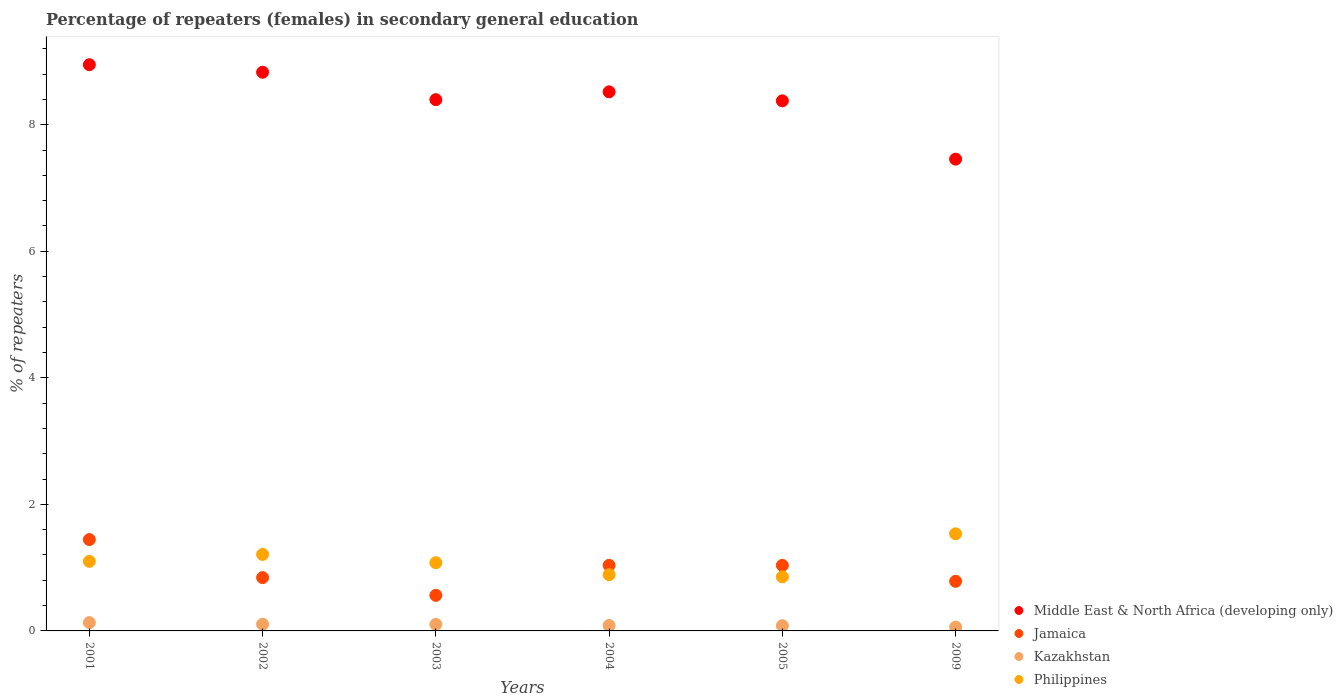Is the number of dotlines equal to the number of legend labels?
Provide a short and direct response. Yes. What is the percentage of female repeaters in Philippines in 2003?
Your response must be concise. 1.08. Across all years, what is the maximum percentage of female repeaters in Jamaica?
Your response must be concise. 1.44. Across all years, what is the minimum percentage of female repeaters in Philippines?
Keep it short and to the point. 0.85. What is the total percentage of female repeaters in Middle East & North Africa (developing only) in the graph?
Offer a very short reply. 50.53. What is the difference between the percentage of female repeaters in Philippines in 2003 and that in 2004?
Your answer should be compact. 0.19. What is the difference between the percentage of female repeaters in Middle East & North Africa (developing only) in 2004 and the percentage of female repeaters in Kazakhstan in 2002?
Provide a short and direct response. 8.41. What is the average percentage of female repeaters in Jamaica per year?
Offer a terse response. 0.95. In the year 2005, what is the difference between the percentage of female repeaters in Jamaica and percentage of female repeaters in Middle East & North Africa (developing only)?
Give a very brief answer. -7.34. In how many years, is the percentage of female repeaters in Kazakhstan greater than 0.8 %?
Your response must be concise. 0. What is the ratio of the percentage of female repeaters in Philippines in 2001 to that in 2002?
Keep it short and to the point. 0.91. Is the percentage of female repeaters in Middle East & North Africa (developing only) in 2004 less than that in 2009?
Provide a short and direct response. No. What is the difference between the highest and the second highest percentage of female repeaters in Kazakhstan?
Offer a very short reply. 0.03. What is the difference between the highest and the lowest percentage of female repeaters in Philippines?
Offer a very short reply. 0.68. In how many years, is the percentage of female repeaters in Middle East & North Africa (developing only) greater than the average percentage of female repeaters in Middle East & North Africa (developing only) taken over all years?
Provide a short and direct response. 3. Is the sum of the percentage of female repeaters in Kazakhstan in 2004 and 2009 greater than the maximum percentage of female repeaters in Philippines across all years?
Make the answer very short. No. Is it the case that in every year, the sum of the percentage of female repeaters in Middle East & North Africa (developing only) and percentage of female repeaters in Philippines  is greater than the sum of percentage of female repeaters in Kazakhstan and percentage of female repeaters in Jamaica?
Your answer should be very brief. No. Is it the case that in every year, the sum of the percentage of female repeaters in Jamaica and percentage of female repeaters in Middle East & North Africa (developing only)  is greater than the percentage of female repeaters in Philippines?
Provide a short and direct response. Yes. Are the values on the major ticks of Y-axis written in scientific E-notation?
Your response must be concise. No. Does the graph contain grids?
Give a very brief answer. No. How are the legend labels stacked?
Keep it short and to the point. Vertical. What is the title of the graph?
Give a very brief answer. Percentage of repeaters (females) in secondary general education. Does "Seychelles" appear as one of the legend labels in the graph?
Your answer should be compact. No. What is the label or title of the X-axis?
Ensure brevity in your answer.  Years. What is the label or title of the Y-axis?
Offer a terse response. % of repeaters. What is the % of repeaters in Middle East & North Africa (developing only) in 2001?
Ensure brevity in your answer.  8.95. What is the % of repeaters of Jamaica in 2001?
Make the answer very short. 1.44. What is the % of repeaters in Kazakhstan in 2001?
Offer a very short reply. 0.13. What is the % of repeaters in Philippines in 2001?
Keep it short and to the point. 1.1. What is the % of repeaters of Middle East & North Africa (developing only) in 2002?
Give a very brief answer. 8.83. What is the % of repeaters in Jamaica in 2002?
Offer a very short reply. 0.84. What is the % of repeaters in Kazakhstan in 2002?
Offer a very short reply. 0.11. What is the % of repeaters of Philippines in 2002?
Offer a terse response. 1.21. What is the % of repeaters in Middle East & North Africa (developing only) in 2003?
Offer a terse response. 8.4. What is the % of repeaters of Jamaica in 2003?
Ensure brevity in your answer.  0.56. What is the % of repeaters in Kazakhstan in 2003?
Offer a very short reply. 0.1. What is the % of repeaters of Philippines in 2003?
Your answer should be compact. 1.08. What is the % of repeaters in Middle East & North Africa (developing only) in 2004?
Provide a succinct answer. 8.52. What is the % of repeaters in Jamaica in 2004?
Provide a succinct answer. 1.04. What is the % of repeaters in Kazakhstan in 2004?
Make the answer very short. 0.09. What is the % of repeaters of Philippines in 2004?
Make the answer very short. 0.89. What is the % of repeaters in Middle East & North Africa (developing only) in 2005?
Offer a very short reply. 8.38. What is the % of repeaters of Jamaica in 2005?
Ensure brevity in your answer.  1.04. What is the % of repeaters in Kazakhstan in 2005?
Ensure brevity in your answer.  0.08. What is the % of repeaters of Philippines in 2005?
Your answer should be compact. 0.85. What is the % of repeaters of Middle East & North Africa (developing only) in 2009?
Offer a terse response. 7.46. What is the % of repeaters of Jamaica in 2009?
Offer a very short reply. 0.78. What is the % of repeaters in Kazakhstan in 2009?
Your answer should be compact. 0.06. What is the % of repeaters in Philippines in 2009?
Your answer should be very brief. 1.53. Across all years, what is the maximum % of repeaters in Middle East & North Africa (developing only)?
Ensure brevity in your answer.  8.95. Across all years, what is the maximum % of repeaters in Jamaica?
Your response must be concise. 1.44. Across all years, what is the maximum % of repeaters in Kazakhstan?
Your answer should be very brief. 0.13. Across all years, what is the maximum % of repeaters of Philippines?
Provide a succinct answer. 1.53. Across all years, what is the minimum % of repeaters of Middle East & North Africa (developing only)?
Your response must be concise. 7.46. Across all years, what is the minimum % of repeaters of Jamaica?
Your response must be concise. 0.56. Across all years, what is the minimum % of repeaters of Kazakhstan?
Your answer should be very brief. 0.06. Across all years, what is the minimum % of repeaters of Philippines?
Offer a terse response. 0.85. What is the total % of repeaters of Middle East & North Africa (developing only) in the graph?
Give a very brief answer. 50.53. What is the total % of repeaters in Jamaica in the graph?
Your answer should be very brief. 5.71. What is the total % of repeaters in Kazakhstan in the graph?
Provide a short and direct response. 0.57. What is the total % of repeaters in Philippines in the graph?
Provide a succinct answer. 6.66. What is the difference between the % of repeaters of Middle East & North Africa (developing only) in 2001 and that in 2002?
Your answer should be very brief. 0.12. What is the difference between the % of repeaters of Jamaica in 2001 and that in 2002?
Your answer should be very brief. 0.6. What is the difference between the % of repeaters of Kazakhstan in 2001 and that in 2002?
Make the answer very short. 0.03. What is the difference between the % of repeaters of Philippines in 2001 and that in 2002?
Give a very brief answer. -0.11. What is the difference between the % of repeaters in Middle East & North Africa (developing only) in 2001 and that in 2003?
Your answer should be very brief. 0.55. What is the difference between the % of repeaters in Jamaica in 2001 and that in 2003?
Offer a very short reply. 0.88. What is the difference between the % of repeaters in Kazakhstan in 2001 and that in 2003?
Give a very brief answer. 0.03. What is the difference between the % of repeaters in Philippines in 2001 and that in 2003?
Your response must be concise. 0.02. What is the difference between the % of repeaters of Middle East & North Africa (developing only) in 2001 and that in 2004?
Ensure brevity in your answer.  0.43. What is the difference between the % of repeaters of Jamaica in 2001 and that in 2004?
Keep it short and to the point. 0.41. What is the difference between the % of repeaters in Kazakhstan in 2001 and that in 2004?
Give a very brief answer. 0.05. What is the difference between the % of repeaters in Philippines in 2001 and that in 2004?
Your response must be concise. 0.21. What is the difference between the % of repeaters in Middle East & North Africa (developing only) in 2001 and that in 2005?
Make the answer very short. 0.57. What is the difference between the % of repeaters in Jamaica in 2001 and that in 2005?
Make the answer very short. 0.41. What is the difference between the % of repeaters in Kazakhstan in 2001 and that in 2005?
Give a very brief answer. 0.05. What is the difference between the % of repeaters of Philippines in 2001 and that in 2005?
Your answer should be compact. 0.24. What is the difference between the % of repeaters of Middle East & North Africa (developing only) in 2001 and that in 2009?
Make the answer very short. 1.49. What is the difference between the % of repeaters in Jamaica in 2001 and that in 2009?
Your answer should be very brief. 0.66. What is the difference between the % of repeaters in Kazakhstan in 2001 and that in 2009?
Keep it short and to the point. 0.07. What is the difference between the % of repeaters of Philippines in 2001 and that in 2009?
Your answer should be very brief. -0.44. What is the difference between the % of repeaters in Middle East & North Africa (developing only) in 2002 and that in 2003?
Your answer should be compact. 0.43. What is the difference between the % of repeaters of Jamaica in 2002 and that in 2003?
Keep it short and to the point. 0.28. What is the difference between the % of repeaters in Kazakhstan in 2002 and that in 2003?
Ensure brevity in your answer.  0. What is the difference between the % of repeaters in Philippines in 2002 and that in 2003?
Offer a terse response. 0.13. What is the difference between the % of repeaters of Middle East & North Africa (developing only) in 2002 and that in 2004?
Give a very brief answer. 0.31. What is the difference between the % of repeaters in Jamaica in 2002 and that in 2004?
Provide a short and direct response. -0.19. What is the difference between the % of repeaters of Kazakhstan in 2002 and that in 2004?
Your response must be concise. 0.02. What is the difference between the % of repeaters of Philippines in 2002 and that in 2004?
Your response must be concise. 0.32. What is the difference between the % of repeaters of Middle East & North Africa (developing only) in 2002 and that in 2005?
Your answer should be very brief. 0.45. What is the difference between the % of repeaters of Jamaica in 2002 and that in 2005?
Keep it short and to the point. -0.19. What is the difference between the % of repeaters of Kazakhstan in 2002 and that in 2005?
Keep it short and to the point. 0.02. What is the difference between the % of repeaters of Philippines in 2002 and that in 2005?
Provide a succinct answer. 0.35. What is the difference between the % of repeaters of Middle East & North Africa (developing only) in 2002 and that in 2009?
Offer a terse response. 1.37. What is the difference between the % of repeaters of Jamaica in 2002 and that in 2009?
Provide a succinct answer. 0.06. What is the difference between the % of repeaters in Kazakhstan in 2002 and that in 2009?
Provide a succinct answer. 0.05. What is the difference between the % of repeaters in Philippines in 2002 and that in 2009?
Provide a short and direct response. -0.33. What is the difference between the % of repeaters of Middle East & North Africa (developing only) in 2003 and that in 2004?
Provide a succinct answer. -0.12. What is the difference between the % of repeaters of Jamaica in 2003 and that in 2004?
Give a very brief answer. -0.47. What is the difference between the % of repeaters of Kazakhstan in 2003 and that in 2004?
Your answer should be very brief. 0.02. What is the difference between the % of repeaters of Philippines in 2003 and that in 2004?
Your response must be concise. 0.19. What is the difference between the % of repeaters of Middle East & North Africa (developing only) in 2003 and that in 2005?
Offer a very short reply. 0.02. What is the difference between the % of repeaters of Jamaica in 2003 and that in 2005?
Provide a short and direct response. -0.47. What is the difference between the % of repeaters in Kazakhstan in 2003 and that in 2005?
Offer a terse response. 0.02. What is the difference between the % of repeaters of Philippines in 2003 and that in 2005?
Give a very brief answer. 0.22. What is the difference between the % of repeaters in Middle East & North Africa (developing only) in 2003 and that in 2009?
Keep it short and to the point. 0.94. What is the difference between the % of repeaters in Jamaica in 2003 and that in 2009?
Provide a succinct answer. -0.22. What is the difference between the % of repeaters of Kazakhstan in 2003 and that in 2009?
Keep it short and to the point. 0.04. What is the difference between the % of repeaters in Philippines in 2003 and that in 2009?
Your response must be concise. -0.46. What is the difference between the % of repeaters of Middle East & North Africa (developing only) in 2004 and that in 2005?
Give a very brief answer. 0.14. What is the difference between the % of repeaters of Jamaica in 2004 and that in 2005?
Keep it short and to the point. -0. What is the difference between the % of repeaters of Kazakhstan in 2004 and that in 2005?
Provide a succinct answer. 0. What is the difference between the % of repeaters of Philippines in 2004 and that in 2005?
Offer a very short reply. 0.03. What is the difference between the % of repeaters of Middle East & North Africa (developing only) in 2004 and that in 2009?
Provide a succinct answer. 1.06. What is the difference between the % of repeaters of Jamaica in 2004 and that in 2009?
Offer a terse response. 0.25. What is the difference between the % of repeaters of Kazakhstan in 2004 and that in 2009?
Keep it short and to the point. 0.03. What is the difference between the % of repeaters of Philippines in 2004 and that in 2009?
Keep it short and to the point. -0.65. What is the difference between the % of repeaters in Middle East & North Africa (developing only) in 2005 and that in 2009?
Your answer should be compact. 0.92. What is the difference between the % of repeaters in Jamaica in 2005 and that in 2009?
Provide a short and direct response. 0.25. What is the difference between the % of repeaters of Kazakhstan in 2005 and that in 2009?
Offer a very short reply. 0.02. What is the difference between the % of repeaters of Philippines in 2005 and that in 2009?
Provide a short and direct response. -0.68. What is the difference between the % of repeaters in Middle East & North Africa (developing only) in 2001 and the % of repeaters in Jamaica in 2002?
Your response must be concise. 8.11. What is the difference between the % of repeaters of Middle East & North Africa (developing only) in 2001 and the % of repeaters of Kazakhstan in 2002?
Offer a terse response. 8.84. What is the difference between the % of repeaters in Middle East & North Africa (developing only) in 2001 and the % of repeaters in Philippines in 2002?
Your answer should be very brief. 7.74. What is the difference between the % of repeaters in Jamaica in 2001 and the % of repeaters in Kazakhstan in 2002?
Keep it short and to the point. 1.34. What is the difference between the % of repeaters in Jamaica in 2001 and the % of repeaters in Philippines in 2002?
Offer a terse response. 0.23. What is the difference between the % of repeaters of Kazakhstan in 2001 and the % of repeaters of Philippines in 2002?
Provide a succinct answer. -1.08. What is the difference between the % of repeaters in Middle East & North Africa (developing only) in 2001 and the % of repeaters in Jamaica in 2003?
Your answer should be very brief. 8.39. What is the difference between the % of repeaters in Middle East & North Africa (developing only) in 2001 and the % of repeaters in Kazakhstan in 2003?
Your answer should be very brief. 8.85. What is the difference between the % of repeaters of Middle East & North Africa (developing only) in 2001 and the % of repeaters of Philippines in 2003?
Your answer should be very brief. 7.87. What is the difference between the % of repeaters of Jamaica in 2001 and the % of repeaters of Kazakhstan in 2003?
Your answer should be compact. 1.34. What is the difference between the % of repeaters of Jamaica in 2001 and the % of repeaters of Philippines in 2003?
Provide a succinct answer. 0.37. What is the difference between the % of repeaters in Kazakhstan in 2001 and the % of repeaters in Philippines in 2003?
Give a very brief answer. -0.95. What is the difference between the % of repeaters in Middle East & North Africa (developing only) in 2001 and the % of repeaters in Jamaica in 2004?
Make the answer very short. 7.91. What is the difference between the % of repeaters of Middle East & North Africa (developing only) in 2001 and the % of repeaters of Kazakhstan in 2004?
Provide a short and direct response. 8.86. What is the difference between the % of repeaters of Middle East & North Africa (developing only) in 2001 and the % of repeaters of Philippines in 2004?
Keep it short and to the point. 8.06. What is the difference between the % of repeaters of Jamaica in 2001 and the % of repeaters of Kazakhstan in 2004?
Ensure brevity in your answer.  1.36. What is the difference between the % of repeaters of Jamaica in 2001 and the % of repeaters of Philippines in 2004?
Make the answer very short. 0.56. What is the difference between the % of repeaters of Kazakhstan in 2001 and the % of repeaters of Philippines in 2004?
Give a very brief answer. -0.76. What is the difference between the % of repeaters of Middle East & North Africa (developing only) in 2001 and the % of repeaters of Jamaica in 2005?
Your answer should be very brief. 7.91. What is the difference between the % of repeaters of Middle East & North Africa (developing only) in 2001 and the % of repeaters of Kazakhstan in 2005?
Make the answer very short. 8.87. What is the difference between the % of repeaters of Middle East & North Africa (developing only) in 2001 and the % of repeaters of Philippines in 2005?
Your response must be concise. 8.09. What is the difference between the % of repeaters in Jamaica in 2001 and the % of repeaters in Kazakhstan in 2005?
Offer a very short reply. 1.36. What is the difference between the % of repeaters in Jamaica in 2001 and the % of repeaters in Philippines in 2005?
Ensure brevity in your answer.  0.59. What is the difference between the % of repeaters of Kazakhstan in 2001 and the % of repeaters of Philippines in 2005?
Give a very brief answer. -0.72. What is the difference between the % of repeaters in Middle East & North Africa (developing only) in 2001 and the % of repeaters in Jamaica in 2009?
Make the answer very short. 8.16. What is the difference between the % of repeaters in Middle East & North Africa (developing only) in 2001 and the % of repeaters in Kazakhstan in 2009?
Provide a succinct answer. 8.89. What is the difference between the % of repeaters in Middle East & North Africa (developing only) in 2001 and the % of repeaters in Philippines in 2009?
Keep it short and to the point. 7.41. What is the difference between the % of repeaters in Jamaica in 2001 and the % of repeaters in Kazakhstan in 2009?
Provide a succinct answer. 1.38. What is the difference between the % of repeaters of Jamaica in 2001 and the % of repeaters of Philippines in 2009?
Your response must be concise. -0.09. What is the difference between the % of repeaters of Kazakhstan in 2001 and the % of repeaters of Philippines in 2009?
Make the answer very short. -1.4. What is the difference between the % of repeaters of Middle East & North Africa (developing only) in 2002 and the % of repeaters of Jamaica in 2003?
Provide a short and direct response. 8.27. What is the difference between the % of repeaters of Middle East & North Africa (developing only) in 2002 and the % of repeaters of Kazakhstan in 2003?
Offer a very short reply. 8.73. What is the difference between the % of repeaters of Middle East & North Africa (developing only) in 2002 and the % of repeaters of Philippines in 2003?
Offer a terse response. 7.75. What is the difference between the % of repeaters of Jamaica in 2002 and the % of repeaters of Kazakhstan in 2003?
Offer a very short reply. 0.74. What is the difference between the % of repeaters of Jamaica in 2002 and the % of repeaters of Philippines in 2003?
Keep it short and to the point. -0.24. What is the difference between the % of repeaters in Kazakhstan in 2002 and the % of repeaters in Philippines in 2003?
Keep it short and to the point. -0.97. What is the difference between the % of repeaters of Middle East & North Africa (developing only) in 2002 and the % of repeaters of Jamaica in 2004?
Keep it short and to the point. 7.79. What is the difference between the % of repeaters of Middle East & North Africa (developing only) in 2002 and the % of repeaters of Kazakhstan in 2004?
Offer a very short reply. 8.74. What is the difference between the % of repeaters of Middle East & North Africa (developing only) in 2002 and the % of repeaters of Philippines in 2004?
Offer a terse response. 7.94. What is the difference between the % of repeaters of Jamaica in 2002 and the % of repeaters of Kazakhstan in 2004?
Provide a succinct answer. 0.76. What is the difference between the % of repeaters of Jamaica in 2002 and the % of repeaters of Philippines in 2004?
Provide a succinct answer. -0.05. What is the difference between the % of repeaters in Kazakhstan in 2002 and the % of repeaters in Philippines in 2004?
Give a very brief answer. -0.78. What is the difference between the % of repeaters in Middle East & North Africa (developing only) in 2002 and the % of repeaters in Jamaica in 2005?
Offer a very short reply. 7.79. What is the difference between the % of repeaters in Middle East & North Africa (developing only) in 2002 and the % of repeaters in Kazakhstan in 2005?
Give a very brief answer. 8.75. What is the difference between the % of repeaters in Middle East & North Africa (developing only) in 2002 and the % of repeaters in Philippines in 2005?
Your answer should be compact. 7.97. What is the difference between the % of repeaters in Jamaica in 2002 and the % of repeaters in Kazakhstan in 2005?
Keep it short and to the point. 0.76. What is the difference between the % of repeaters in Jamaica in 2002 and the % of repeaters in Philippines in 2005?
Provide a short and direct response. -0.01. What is the difference between the % of repeaters in Kazakhstan in 2002 and the % of repeaters in Philippines in 2005?
Ensure brevity in your answer.  -0.75. What is the difference between the % of repeaters in Middle East & North Africa (developing only) in 2002 and the % of repeaters in Jamaica in 2009?
Provide a short and direct response. 8.04. What is the difference between the % of repeaters of Middle East & North Africa (developing only) in 2002 and the % of repeaters of Kazakhstan in 2009?
Provide a succinct answer. 8.77. What is the difference between the % of repeaters of Middle East & North Africa (developing only) in 2002 and the % of repeaters of Philippines in 2009?
Your answer should be compact. 7.29. What is the difference between the % of repeaters in Jamaica in 2002 and the % of repeaters in Kazakhstan in 2009?
Your response must be concise. 0.78. What is the difference between the % of repeaters of Jamaica in 2002 and the % of repeaters of Philippines in 2009?
Ensure brevity in your answer.  -0.69. What is the difference between the % of repeaters of Kazakhstan in 2002 and the % of repeaters of Philippines in 2009?
Give a very brief answer. -1.43. What is the difference between the % of repeaters in Middle East & North Africa (developing only) in 2003 and the % of repeaters in Jamaica in 2004?
Your answer should be very brief. 7.36. What is the difference between the % of repeaters in Middle East & North Africa (developing only) in 2003 and the % of repeaters in Kazakhstan in 2004?
Your answer should be compact. 8.31. What is the difference between the % of repeaters of Middle East & North Africa (developing only) in 2003 and the % of repeaters of Philippines in 2004?
Offer a very short reply. 7.51. What is the difference between the % of repeaters in Jamaica in 2003 and the % of repeaters in Kazakhstan in 2004?
Provide a short and direct response. 0.48. What is the difference between the % of repeaters of Jamaica in 2003 and the % of repeaters of Philippines in 2004?
Your answer should be very brief. -0.33. What is the difference between the % of repeaters of Kazakhstan in 2003 and the % of repeaters of Philippines in 2004?
Your answer should be very brief. -0.79. What is the difference between the % of repeaters in Middle East & North Africa (developing only) in 2003 and the % of repeaters in Jamaica in 2005?
Keep it short and to the point. 7.36. What is the difference between the % of repeaters in Middle East & North Africa (developing only) in 2003 and the % of repeaters in Kazakhstan in 2005?
Ensure brevity in your answer.  8.31. What is the difference between the % of repeaters of Middle East & North Africa (developing only) in 2003 and the % of repeaters of Philippines in 2005?
Ensure brevity in your answer.  7.54. What is the difference between the % of repeaters of Jamaica in 2003 and the % of repeaters of Kazakhstan in 2005?
Give a very brief answer. 0.48. What is the difference between the % of repeaters of Jamaica in 2003 and the % of repeaters of Philippines in 2005?
Make the answer very short. -0.29. What is the difference between the % of repeaters in Kazakhstan in 2003 and the % of repeaters in Philippines in 2005?
Ensure brevity in your answer.  -0.75. What is the difference between the % of repeaters of Middle East & North Africa (developing only) in 2003 and the % of repeaters of Jamaica in 2009?
Provide a succinct answer. 7.61. What is the difference between the % of repeaters in Middle East & North Africa (developing only) in 2003 and the % of repeaters in Kazakhstan in 2009?
Your answer should be compact. 8.34. What is the difference between the % of repeaters of Middle East & North Africa (developing only) in 2003 and the % of repeaters of Philippines in 2009?
Give a very brief answer. 6.86. What is the difference between the % of repeaters in Jamaica in 2003 and the % of repeaters in Kazakhstan in 2009?
Ensure brevity in your answer.  0.5. What is the difference between the % of repeaters of Jamaica in 2003 and the % of repeaters of Philippines in 2009?
Provide a succinct answer. -0.97. What is the difference between the % of repeaters of Kazakhstan in 2003 and the % of repeaters of Philippines in 2009?
Offer a terse response. -1.43. What is the difference between the % of repeaters of Middle East & North Africa (developing only) in 2004 and the % of repeaters of Jamaica in 2005?
Your response must be concise. 7.48. What is the difference between the % of repeaters in Middle East & North Africa (developing only) in 2004 and the % of repeaters in Kazakhstan in 2005?
Keep it short and to the point. 8.44. What is the difference between the % of repeaters in Middle East & North Africa (developing only) in 2004 and the % of repeaters in Philippines in 2005?
Offer a terse response. 7.67. What is the difference between the % of repeaters in Jamaica in 2004 and the % of repeaters in Kazakhstan in 2005?
Give a very brief answer. 0.95. What is the difference between the % of repeaters of Jamaica in 2004 and the % of repeaters of Philippines in 2005?
Your answer should be compact. 0.18. What is the difference between the % of repeaters in Kazakhstan in 2004 and the % of repeaters in Philippines in 2005?
Provide a short and direct response. -0.77. What is the difference between the % of repeaters of Middle East & North Africa (developing only) in 2004 and the % of repeaters of Jamaica in 2009?
Make the answer very short. 7.74. What is the difference between the % of repeaters in Middle East & North Africa (developing only) in 2004 and the % of repeaters in Kazakhstan in 2009?
Your answer should be very brief. 8.46. What is the difference between the % of repeaters of Middle East & North Africa (developing only) in 2004 and the % of repeaters of Philippines in 2009?
Your answer should be compact. 6.99. What is the difference between the % of repeaters in Jamaica in 2004 and the % of repeaters in Kazakhstan in 2009?
Your answer should be very brief. 0.98. What is the difference between the % of repeaters in Jamaica in 2004 and the % of repeaters in Philippines in 2009?
Give a very brief answer. -0.5. What is the difference between the % of repeaters in Kazakhstan in 2004 and the % of repeaters in Philippines in 2009?
Keep it short and to the point. -1.45. What is the difference between the % of repeaters in Middle East & North Africa (developing only) in 2005 and the % of repeaters in Jamaica in 2009?
Your response must be concise. 7.59. What is the difference between the % of repeaters in Middle East & North Africa (developing only) in 2005 and the % of repeaters in Kazakhstan in 2009?
Ensure brevity in your answer.  8.32. What is the difference between the % of repeaters of Middle East & North Africa (developing only) in 2005 and the % of repeaters of Philippines in 2009?
Provide a succinct answer. 6.84. What is the difference between the % of repeaters of Jamaica in 2005 and the % of repeaters of Kazakhstan in 2009?
Make the answer very short. 0.98. What is the difference between the % of repeaters of Jamaica in 2005 and the % of repeaters of Philippines in 2009?
Keep it short and to the point. -0.5. What is the difference between the % of repeaters of Kazakhstan in 2005 and the % of repeaters of Philippines in 2009?
Offer a terse response. -1.45. What is the average % of repeaters of Middle East & North Africa (developing only) per year?
Offer a terse response. 8.42. What is the average % of repeaters of Jamaica per year?
Make the answer very short. 0.95. What is the average % of repeaters of Kazakhstan per year?
Provide a short and direct response. 0.1. What is the average % of repeaters of Philippines per year?
Your answer should be compact. 1.11. In the year 2001, what is the difference between the % of repeaters of Middle East & North Africa (developing only) and % of repeaters of Jamaica?
Give a very brief answer. 7.5. In the year 2001, what is the difference between the % of repeaters of Middle East & North Africa (developing only) and % of repeaters of Kazakhstan?
Your answer should be compact. 8.82. In the year 2001, what is the difference between the % of repeaters in Middle East & North Africa (developing only) and % of repeaters in Philippines?
Offer a very short reply. 7.85. In the year 2001, what is the difference between the % of repeaters of Jamaica and % of repeaters of Kazakhstan?
Offer a terse response. 1.31. In the year 2001, what is the difference between the % of repeaters of Jamaica and % of repeaters of Philippines?
Ensure brevity in your answer.  0.34. In the year 2001, what is the difference between the % of repeaters in Kazakhstan and % of repeaters in Philippines?
Ensure brevity in your answer.  -0.97. In the year 2002, what is the difference between the % of repeaters in Middle East & North Africa (developing only) and % of repeaters in Jamaica?
Offer a terse response. 7.99. In the year 2002, what is the difference between the % of repeaters of Middle East & North Africa (developing only) and % of repeaters of Kazakhstan?
Your answer should be very brief. 8.72. In the year 2002, what is the difference between the % of repeaters of Middle East & North Africa (developing only) and % of repeaters of Philippines?
Ensure brevity in your answer.  7.62. In the year 2002, what is the difference between the % of repeaters of Jamaica and % of repeaters of Kazakhstan?
Make the answer very short. 0.74. In the year 2002, what is the difference between the % of repeaters of Jamaica and % of repeaters of Philippines?
Make the answer very short. -0.37. In the year 2002, what is the difference between the % of repeaters in Kazakhstan and % of repeaters in Philippines?
Your answer should be very brief. -1.1. In the year 2003, what is the difference between the % of repeaters of Middle East & North Africa (developing only) and % of repeaters of Jamaica?
Offer a very short reply. 7.83. In the year 2003, what is the difference between the % of repeaters of Middle East & North Africa (developing only) and % of repeaters of Kazakhstan?
Your answer should be compact. 8.29. In the year 2003, what is the difference between the % of repeaters of Middle East & North Africa (developing only) and % of repeaters of Philippines?
Offer a very short reply. 7.32. In the year 2003, what is the difference between the % of repeaters of Jamaica and % of repeaters of Kazakhstan?
Your answer should be compact. 0.46. In the year 2003, what is the difference between the % of repeaters in Jamaica and % of repeaters in Philippines?
Make the answer very short. -0.52. In the year 2003, what is the difference between the % of repeaters in Kazakhstan and % of repeaters in Philippines?
Make the answer very short. -0.97. In the year 2004, what is the difference between the % of repeaters of Middle East & North Africa (developing only) and % of repeaters of Jamaica?
Make the answer very short. 7.48. In the year 2004, what is the difference between the % of repeaters in Middle East & North Africa (developing only) and % of repeaters in Kazakhstan?
Offer a very short reply. 8.43. In the year 2004, what is the difference between the % of repeaters in Middle East & North Africa (developing only) and % of repeaters in Philippines?
Keep it short and to the point. 7.63. In the year 2004, what is the difference between the % of repeaters in Jamaica and % of repeaters in Philippines?
Keep it short and to the point. 0.15. In the year 2004, what is the difference between the % of repeaters of Kazakhstan and % of repeaters of Philippines?
Your answer should be very brief. -0.8. In the year 2005, what is the difference between the % of repeaters in Middle East & North Africa (developing only) and % of repeaters in Jamaica?
Your answer should be compact. 7.34. In the year 2005, what is the difference between the % of repeaters of Middle East & North Africa (developing only) and % of repeaters of Kazakhstan?
Offer a terse response. 8.29. In the year 2005, what is the difference between the % of repeaters of Middle East & North Africa (developing only) and % of repeaters of Philippines?
Give a very brief answer. 7.52. In the year 2005, what is the difference between the % of repeaters in Jamaica and % of repeaters in Kazakhstan?
Provide a short and direct response. 0.95. In the year 2005, what is the difference between the % of repeaters in Jamaica and % of repeaters in Philippines?
Give a very brief answer. 0.18. In the year 2005, what is the difference between the % of repeaters of Kazakhstan and % of repeaters of Philippines?
Your response must be concise. -0.77. In the year 2009, what is the difference between the % of repeaters in Middle East & North Africa (developing only) and % of repeaters in Jamaica?
Make the answer very short. 6.67. In the year 2009, what is the difference between the % of repeaters in Middle East & North Africa (developing only) and % of repeaters in Kazakhstan?
Your answer should be compact. 7.4. In the year 2009, what is the difference between the % of repeaters of Middle East & North Africa (developing only) and % of repeaters of Philippines?
Offer a very short reply. 5.92. In the year 2009, what is the difference between the % of repeaters of Jamaica and % of repeaters of Kazakhstan?
Offer a terse response. 0.72. In the year 2009, what is the difference between the % of repeaters of Jamaica and % of repeaters of Philippines?
Offer a terse response. -0.75. In the year 2009, what is the difference between the % of repeaters in Kazakhstan and % of repeaters in Philippines?
Ensure brevity in your answer.  -1.47. What is the ratio of the % of repeaters of Middle East & North Africa (developing only) in 2001 to that in 2002?
Your response must be concise. 1.01. What is the ratio of the % of repeaters in Jamaica in 2001 to that in 2002?
Provide a short and direct response. 1.71. What is the ratio of the % of repeaters of Kazakhstan in 2001 to that in 2002?
Offer a very short reply. 1.24. What is the ratio of the % of repeaters of Philippines in 2001 to that in 2002?
Offer a terse response. 0.91. What is the ratio of the % of repeaters in Middle East & North Africa (developing only) in 2001 to that in 2003?
Make the answer very short. 1.07. What is the ratio of the % of repeaters of Jamaica in 2001 to that in 2003?
Your response must be concise. 2.57. What is the ratio of the % of repeaters of Kazakhstan in 2001 to that in 2003?
Offer a very short reply. 1.27. What is the ratio of the % of repeaters in Philippines in 2001 to that in 2003?
Provide a short and direct response. 1.02. What is the ratio of the % of repeaters of Middle East & North Africa (developing only) in 2001 to that in 2004?
Provide a short and direct response. 1.05. What is the ratio of the % of repeaters in Jamaica in 2001 to that in 2004?
Your answer should be very brief. 1.39. What is the ratio of the % of repeaters of Kazakhstan in 2001 to that in 2004?
Make the answer very short. 1.53. What is the ratio of the % of repeaters in Philippines in 2001 to that in 2004?
Offer a terse response. 1.24. What is the ratio of the % of repeaters in Middle East & North Africa (developing only) in 2001 to that in 2005?
Your answer should be compact. 1.07. What is the ratio of the % of repeaters of Jamaica in 2001 to that in 2005?
Offer a terse response. 1.39. What is the ratio of the % of repeaters in Kazakhstan in 2001 to that in 2005?
Provide a short and direct response. 1.59. What is the ratio of the % of repeaters in Philippines in 2001 to that in 2005?
Provide a succinct answer. 1.29. What is the ratio of the % of repeaters of Middle East & North Africa (developing only) in 2001 to that in 2009?
Keep it short and to the point. 1.2. What is the ratio of the % of repeaters in Jamaica in 2001 to that in 2009?
Provide a succinct answer. 1.84. What is the ratio of the % of repeaters of Kazakhstan in 2001 to that in 2009?
Offer a very short reply. 2.17. What is the ratio of the % of repeaters in Philippines in 2001 to that in 2009?
Offer a very short reply. 0.72. What is the ratio of the % of repeaters of Middle East & North Africa (developing only) in 2002 to that in 2003?
Provide a succinct answer. 1.05. What is the ratio of the % of repeaters in Jamaica in 2002 to that in 2003?
Offer a terse response. 1.5. What is the ratio of the % of repeaters of Kazakhstan in 2002 to that in 2003?
Your answer should be compact. 1.02. What is the ratio of the % of repeaters in Philippines in 2002 to that in 2003?
Ensure brevity in your answer.  1.12. What is the ratio of the % of repeaters in Middle East & North Africa (developing only) in 2002 to that in 2004?
Offer a very short reply. 1.04. What is the ratio of the % of repeaters in Jamaica in 2002 to that in 2004?
Offer a very short reply. 0.81. What is the ratio of the % of repeaters of Kazakhstan in 2002 to that in 2004?
Your response must be concise. 1.23. What is the ratio of the % of repeaters of Philippines in 2002 to that in 2004?
Give a very brief answer. 1.36. What is the ratio of the % of repeaters in Middle East & North Africa (developing only) in 2002 to that in 2005?
Ensure brevity in your answer.  1.05. What is the ratio of the % of repeaters in Jamaica in 2002 to that in 2005?
Provide a short and direct response. 0.81. What is the ratio of the % of repeaters in Kazakhstan in 2002 to that in 2005?
Offer a terse response. 1.28. What is the ratio of the % of repeaters in Philippines in 2002 to that in 2005?
Offer a terse response. 1.42. What is the ratio of the % of repeaters of Middle East & North Africa (developing only) in 2002 to that in 2009?
Ensure brevity in your answer.  1.18. What is the ratio of the % of repeaters of Jamaica in 2002 to that in 2009?
Offer a terse response. 1.07. What is the ratio of the % of repeaters of Kazakhstan in 2002 to that in 2009?
Keep it short and to the point. 1.74. What is the ratio of the % of repeaters of Philippines in 2002 to that in 2009?
Provide a succinct answer. 0.79. What is the ratio of the % of repeaters of Middle East & North Africa (developing only) in 2003 to that in 2004?
Keep it short and to the point. 0.99. What is the ratio of the % of repeaters of Jamaica in 2003 to that in 2004?
Ensure brevity in your answer.  0.54. What is the ratio of the % of repeaters in Kazakhstan in 2003 to that in 2004?
Provide a short and direct response. 1.2. What is the ratio of the % of repeaters of Philippines in 2003 to that in 2004?
Keep it short and to the point. 1.21. What is the ratio of the % of repeaters of Jamaica in 2003 to that in 2005?
Offer a terse response. 0.54. What is the ratio of the % of repeaters in Kazakhstan in 2003 to that in 2005?
Your response must be concise. 1.25. What is the ratio of the % of repeaters in Philippines in 2003 to that in 2005?
Offer a terse response. 1.26. What is the ratio of the % of repeaters of Middle East & North Africa (developing only) in 2003 to that in 2009?
Provide a short and direct response. 1.13. What is the ratio of the % of repeaters of Jamaica in 2003 to that in 2009?
Offer a very short reply. 0.72. What is the ratio of the % of repeaters of Kazakhstan in 2003 to that in 2009?
Keep it short and to the point. 1.7. What is the ratio of the % of repeaters in Philippines in 2003 to that in 2009?
Ensure brevity in your answer.  0.7. What is the ratio of the % of repeaters in Middle East & North Africa (developing only) in 2004 to that in 2005?
Provide a short and direct response. 1.02. What is the ratio of the % of repeaters of Kazakhstan in 2004 to that in 2005?
Offer a very short reply. 1.04. What is the ratio of the % of repeaters in Philippines in 2004 to that in 2005?
Offer a terse response. 1.04. What is the ratio of the % of repeaters in Middle East & North Africa (developing only) in 2004 to that in 2009?
Your response must be concise. 1.14. What is the ratio of the % of repeaters of Jamaica in 2004 to that in 2009?
Provide a succinct answer. 1.32. What is the ratio of the % of repeaters in Kazakhstan in 2004 to that in 2009?
Keep it short and to the point. 1.42. What is the ratio of the % of repeaters in Philippines in 2004 to that in 2009?
Your response must be concise. 0.58. What is the ratio of the % of repeaters in Middle East & North Africa (developing only) in 2005 to that in 2009?
Your answer should be very brief. 1.12. What is the ratio of the % of repeaters of Jamaica in 2005 to that in 2009?
Offer a very short reply. 1.32. What is the ratio of the % of repeaters in Kazakhstan in 2005 to that in 2009?
Provide a short and direct response. 1.36. What is the ratio of the % of repeaters in Philippines in 2005 to that in 2009?
Make the answer very short. 0.56. What is the difference between the highest and the second highest % of repeaters in Middle East & North Africa (developing only)?
Offer a terse response. 0.12. What is the difference between the highest and the second highest % of repeaters in Jamaica?
Give a very brief answer. 0.41. What is the difference between the highest and the second highest % of repeaters in Kazakhstan?
Keep it short and to the point. 0.03. What is the difference between the highest and the second highest % of repeaters in Philippines?
Offer a very short reply. 0.33. What is the difference between the highest and the lowest % of repeaters of Middle East & North Africa (developing only)?
Your response must be concise. 1.49. What is the difference between the highest and the lowest % of repeaters in Jamaica?
Provide a short and direct response. 0.88. What is the difference between the highest and the lowest % of repeaters of Kazakhstan?
Your response must be concise. 0.07. What is the difference between the highest and the lowest % of repeaters of Philippines?
Offer a terse response. 0.68. 